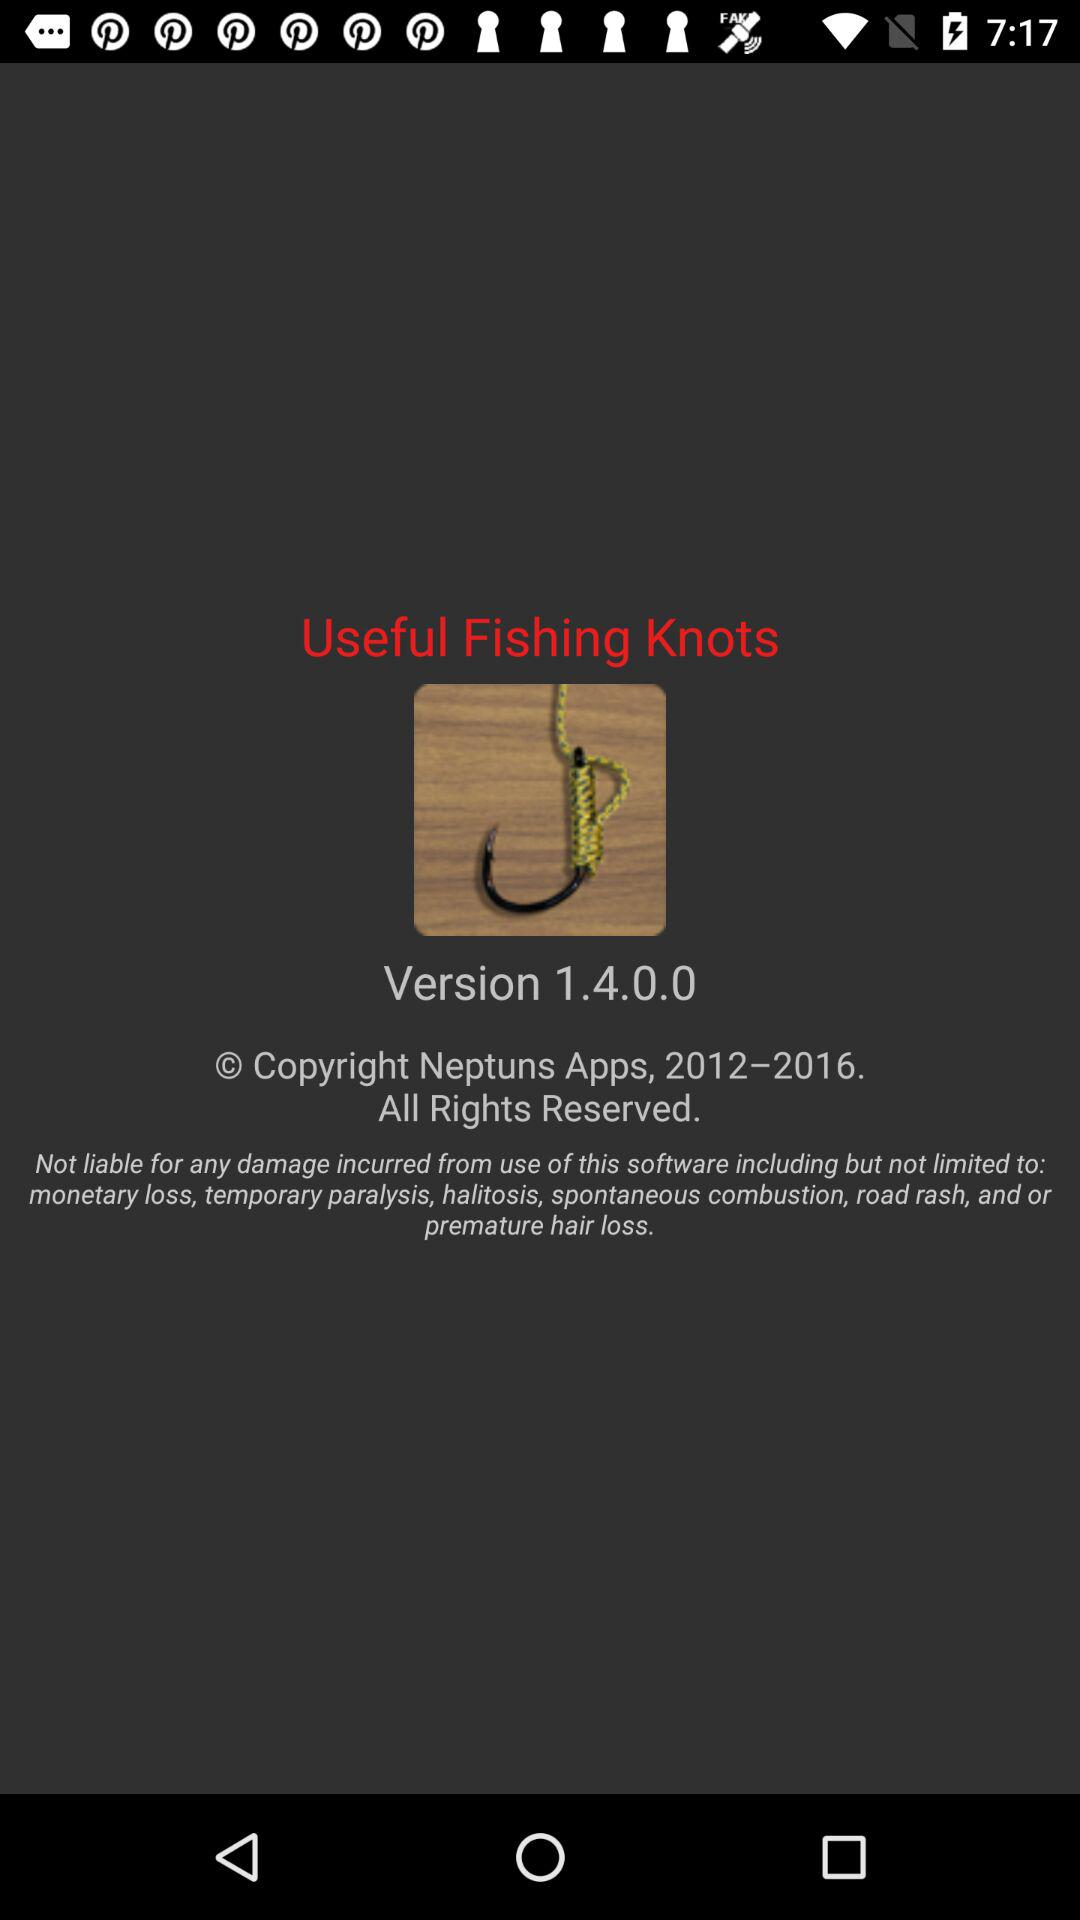What is the version? The version is 1.4.0.0. 